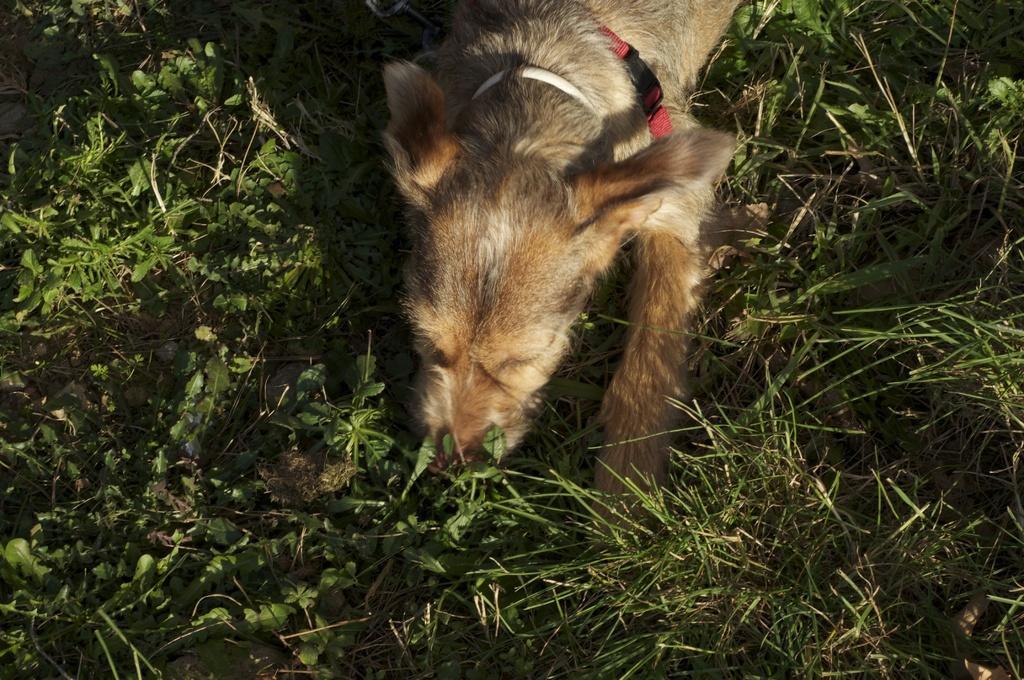Describe this image in one or two sentences. In this picture we can see a dog is lying on the ground. In the background of the image we can see the plants. 